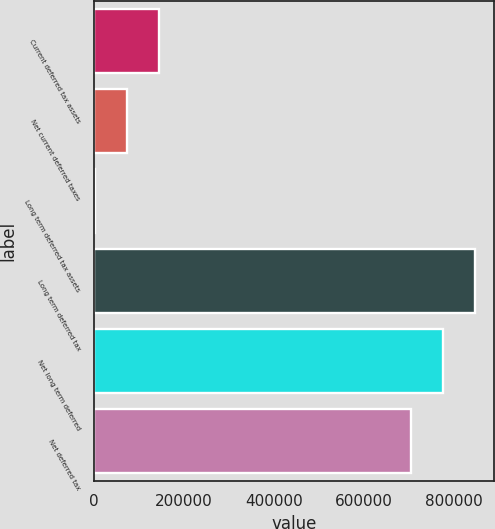<chart> <loc_0><loc_0><loc_500><loc_500><bar_chart><fcel>Current deferred tax assets<fcel>Net current deferred taxes<fcel>Long term deferred tax assets<fcel>Long term deferred tax<fcel>Net long term deferred<fcel>Net deferred tax<nl><fcel>144325<fcel>72981.8<fcel>1639<fcel>847201<fcel>775858<fcel>704515<nl></chart> 